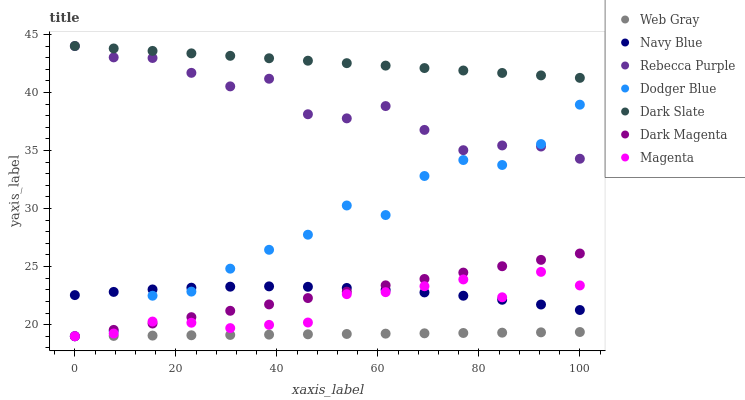Does Web Gray have the minimum area under the curve?
Answer yes or no. Yes. Does Dark Slate have the maximum area under the curve?
Answer yes or no. Yes. Does Dark Magenta have the minimum area under the curve?
Answer yes or no. No. Does Dark Magenta have the maximum area under the curve?
Answer yes or no. No. Is Web Gray the smoothest?
Answer yes or no. Yes. Is Dodger Blue the roughest?
Answer yes or no. Yes. Is Dark Magenta the smoothest?
Answer yes or no. No. Is Dark Magenta the roughest?
Answer yes or no. No. Does Web Gray have the lowest value?
Answer yes or no. Yes. Does Navy Blue have the lowest value?
Answer yes or no. No. Does Rebecca Purple have the highest value?
Answer yes or no. Yes. Does Dark Magenta have the highest value?
Answer yes or no. No. Is Web Gray less than Navy Blue?
Answer yes or no. Yes. Is Dark Slate greater than Dark Magenta?
Answer yes or no. Yes. Does Dark Magenta intersect Navy Blue?
Answer yes or no. Yes. Is Dark Magenta less than Navy Blue?
Answer yes or no. No. Is Dark Magenta greater than Navy Blue?
Answer yes or no. No. Does Web Gray intersect Navy Blue?
Answer yes or no. No. 